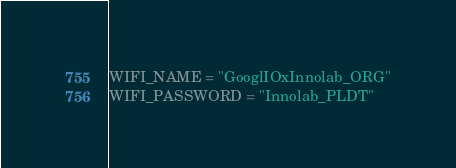<code> <loc_0><loc_0><loc_500><loc_500><_Python_>WIFI_NAME = "GooglIOxInnolab_ORG"
WIFI_PASSWORD = "Innolab_PLDT"</code> 